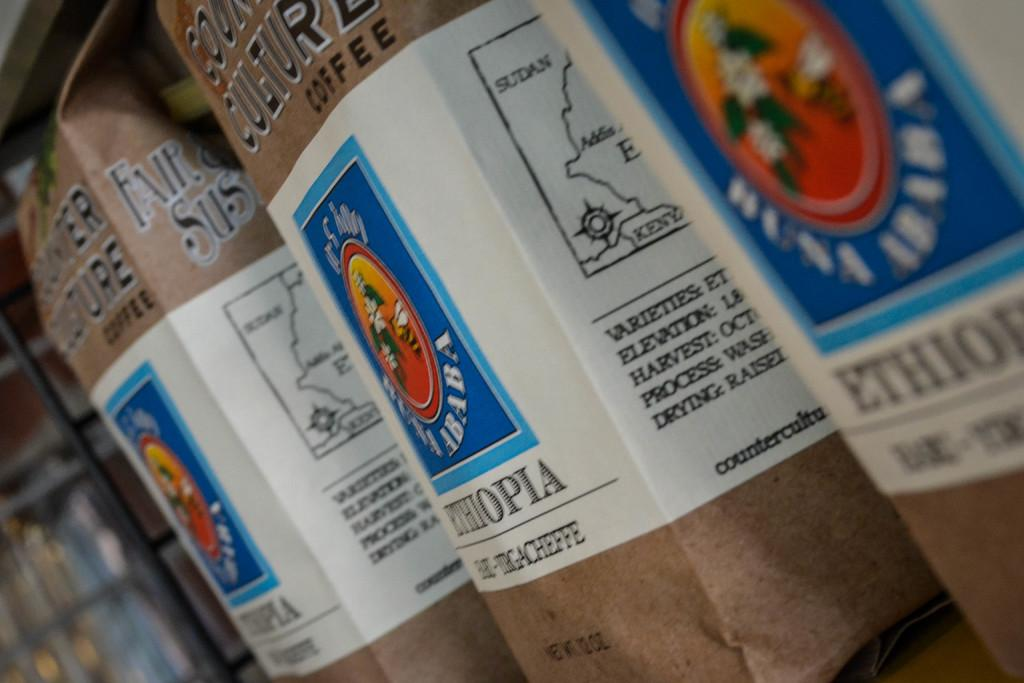<image>
Share a concise interpretation of the image provided. bags of substance that have coffee from ethiopia 